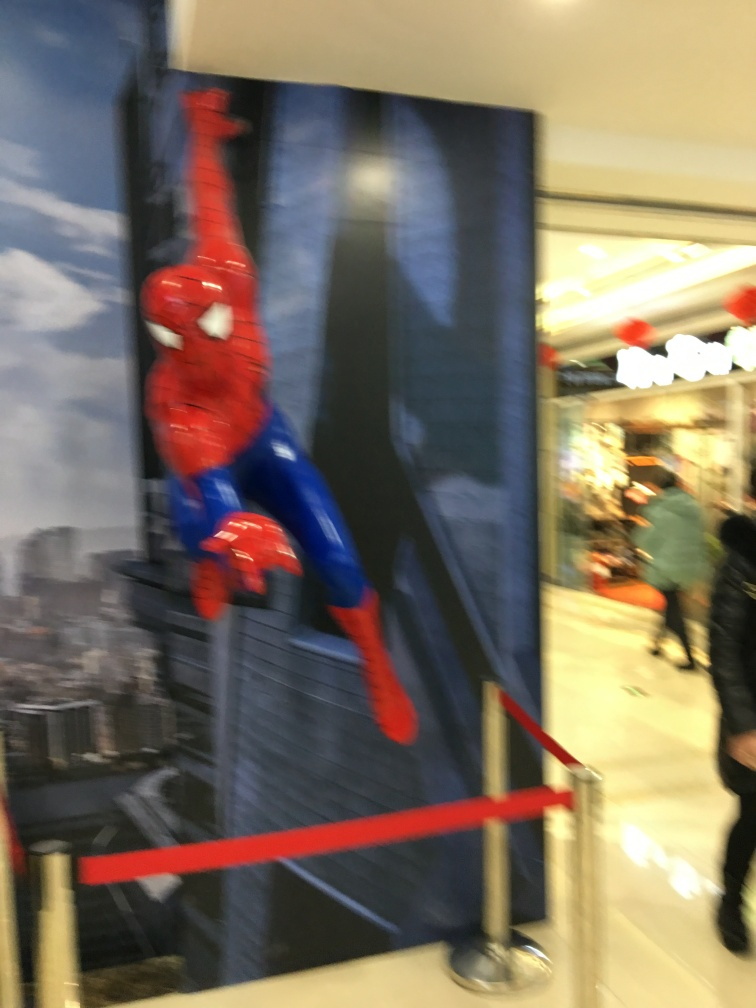Why does the image appear blurry? The blurriness in the image is likely due to camera motion during the photo's capture or a low shutter speed, which can cause the subjects to appear less sharp if they're moving or if the camera is not held steady. 